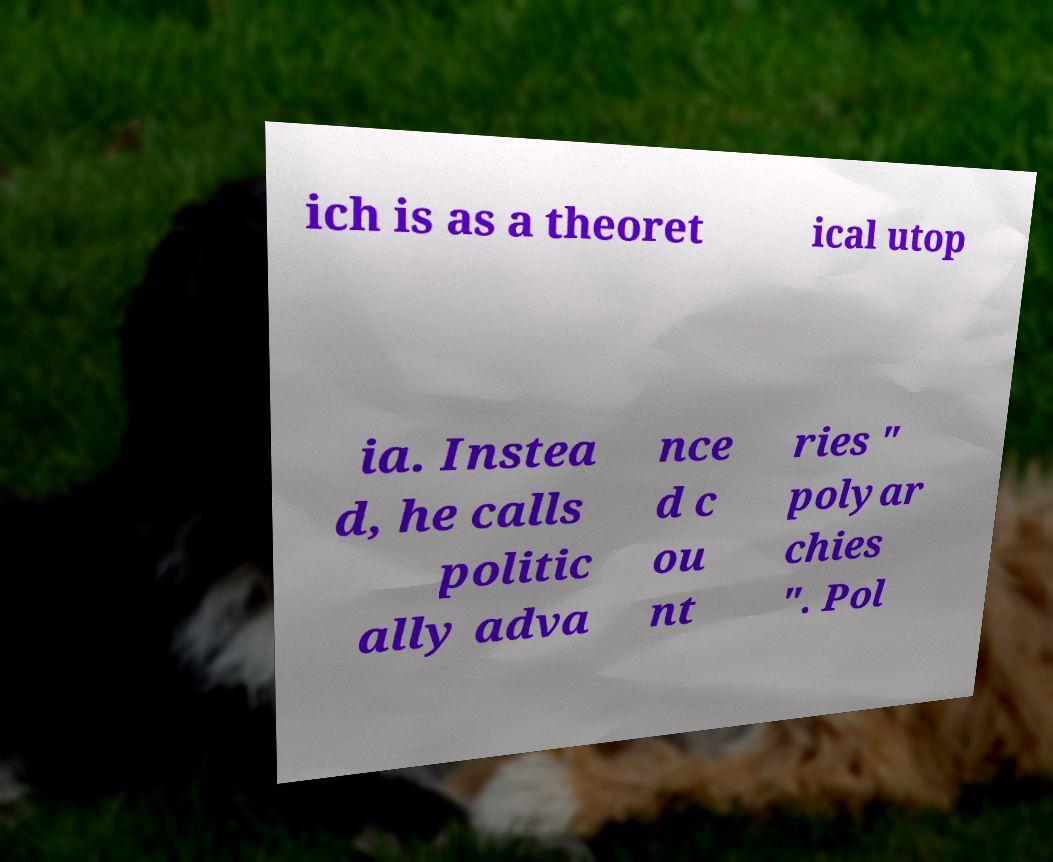Please read and relay the text visible in this image. What does it say? ich is as a theoret ical utop ia. Instea d, he calls politic ally adva nce d c ou nt ries " polyar chies ". Pol 